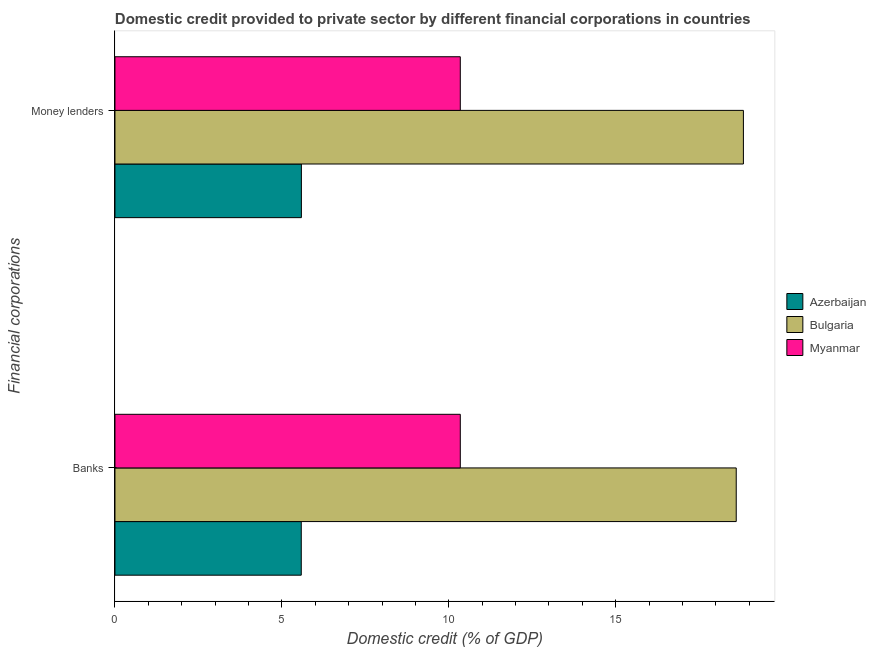How many groups of bars are there?
Offer a terse response. 2. Are the number of bars per tick equal to the number of legend labels?
Keep it short and to the point. Yes. How many bars are there on the 2nd tick from the bottom?
Offer a very short reply. 3. What is the label of the 1st group of bars from the top?
Give a very brief answer. Money lenders. What is the domestic credit provided by money lenders in Azerbaijan?
Offer a very short reply. 5.58. Across all countries, what is the maximum domestic credit provided by banks?
Your answer should be compact. 18.61. Across all countries, what is the minimum domestic credit provided by banks?
Your answer should be compact. 5.58. In which country was the domestic credit provided by money lenders maximum?
Your answer should be compact. Bulgaria. In which country was the domestic credit provided by money lenders minimum?
Provide a succinct answer. Azerbaijan. What is the total domestic credit provided by money lenders in the graph?
Keep it short and to the point. 34.76. What is the difference between the domestic credit provided by money lenders in Azerbaijan and that in Bulgaria?
Give a very brief answer. -13.24. What is the difference between the domestic credit provided by banks in Myanmar and the domestic credit provided by money lenders in Bulgaria?
Offer a terse response. -8.48. What is the average domestic credit provided by money lenders per country?
Make the answer very short. 11.59. What is the difference between the domestic credit provided by money lenders and domestic credit provided by banks in Azerbaijan?
Keep it short and to the point. 0. In how many countries, is the domestic credit provided by banks greater than 4 %?
Offer a terse response. 3. What is the ratio of the domestic credit provided by money lenders in Myanmar to that in Bulgaria?
Provide a succinct answer. 0.55. Is the domestic credit provided by money lenders in Bulgaria less than that in Azerbaijan?
Ensure brevity in your answer.  No. In how many countries, is the domestic credit provided by money lenders greater than the average domestic credit provided by money lenders taken over all countries?
Make the answer very short. 1. What does the 1st bar from the top in Money lenders represents?
Your response must be concise. Myanmar. What does the 1st bar from the bottom in Money lenders represents?
Make the answer very short. Azerbaijan. How many bars are there?
Ensure brevity in your answer.  6. Are all the bars in the graph horizontal?
Ensure brevity in your answer.  Yes. Are the values on the major ticks of X-axis written in scientific E-notation?
Give a very brief answer. No. Does the graph contain any zero values?
Make the answer very short. No. Does the graph contain grids?
Your answer should be compact. No. How many legend labels are there?
Your answer should be compact. 3. How are the legend labels stacked?
Give a very brief answer. Vertical. What is the title of the graph?
Your response must be concise. Domestic credit provided to private sector by different financial corporations in countries. What is the label or title of the X-axis?
Make the answer very short. Domestic credit (% of GDP). What is the label or title of the Y-axis?
Your answer should be very brief. Financial corporations. What is the Domestic credit (% of GDP) of Azerbaijan in Banks?
Your answer should be compact. 5.58. What is the Domestic credit (% of GDP) of Bulgaria in Banks?
Ensure brevity in your answer.  18.61. What is the Domestic credit (% of GDP) in Myanmar in Banks?
Your answer should be compact. 10.34. What is the Domestic credit (% of GDP) of Azerbaijan in Money lenders?
Offer a very short reply. 5.58. What is the Domestic credit (% of GDP) in Bulgaria in Money lenders?
Give a very brief answer. 18.83. What is the Domestic credit (% of GDP) in Myanmar in Money lenders?
Keep it short and to the point. 10.34. Across all Financial corporations, what is the maximum Domestic credit (% of GDP) of Azerbaijan?
Make the answer very short. 5.58. Across all Financial corporations, what is the maximum Domestic credit (% of GDP) in Bulgaria?
Give a very brief answer. 18.83. Across all Financial corporations, what is the maximum Domestic credit (% of GDP) of Myanmar?
Your answer should be compact. 10.34. Across all Financial corporations, what is the minimum Domestic credit (% of GDP) of Azerbaijan?
Your answer should be very brief. 5.58. Across all Financial corporations, what is the minimum Domestic credit (% of GDP) of Bulgaria?
Offer a terse response. 18.61. Across all Financial corporations, what is the minimum Domestic credit (% of GDP) in Myanmar?
Your response must be concise. 10.34. What is the total Domestic credit (% of GDP) of Azerbaijan in the graph?
Offer a very short reply. 11.17. What is the total Domestic credit (% of GDP) in Bulgaria in the graph?
Your response must be concise. 37.44. What is the total Domestic credit (% of GDP) in Myanmar in the graph?
Provide a short and direct response. 20.69. What is the difference between the Domestic credit (% of GDP) of Azerbaijan in Banks and that in Money lenders?
Give a very brief answer. -0. What is the difference between the Domestic credit (% of GDP) of Bulgaria in Banks and that in Money lenders?
Provide a short and direct response. -0.22. What is the difference between the Domestic credit (% of GDP) of Azerbaijan in Banks and the Domestic credit (% of GDP) of Bulgaria in Money lenders?
Offer a very short reply. -13.25. What is the difference between the Domestic credit (% of GDP) in Azerbaijan in Banks and the Domestic credit (% of GDP) in Myanmar in Money lenders?
Your response must be concise. -4.76. What is the difference between the Domestic credit (% of GDP) of Bulgaria in Banks and the Domestic credit (% of GDP) of Myanmar in Money lenders?
Offer a terse response. 8.27. What is the average Domestic credit (% of GDP) in Azerbaijan per Financial corporations?
Provide a succinct answer. 5.58. What is the average Domestic credit (% of GDP) of Bulgaria per Financial corporations?
Provide a succinct answer. 18.72. What is the average Domestic credit (% of GDP) in Myanmar per Financial corporations?
Make the answer very short. 10.34. What is the difference between the Domestic credit (% of GDP) in Azerbaijan and Domestic credit (% of GDP) in Bulgaria in Banks?
Make the answer very short. -13.03. What is the difference between the Domestic credit (% of GDP) of Azerbaijan and Domestic credit (% of GDP) of Myanmar in Banks?
Provide a short and direct response. -4.76. What is the difference between the Domestic credit (% of GDP) of Bulgaria and Domestic credit (% of GDP) of Myanmar in Banks?
Offer a very short reply. 8.27. What is the difference between the Domestic credit (% of GDP) in Azerbaijan and Domestic credit (% of GDP) in Bulgaria in Money lenders?
Make the answer very short. -13.24. What is the difference between the Domestic credit (% of GDP) of Azerbaijan and Domestic credit (% of GDP) of Myanmar in Money lenders?
Your answer should be compact. -4.76. What is the difference between the Domestic credit (% of GDP) in Bulgaria and Domestic credit (% of GDP) in Myanmar in Money lenders?
Provide a succinct answer. 8.48. What is the ratio of the Domestic credit (% of GDP) of Azerbaijan in Banks to that in Money lenders?
Offer a very short reply. 1. What is the ratio of the Domestic credit (% of GDP) in Bulgaria in Banks to that in Money lenders?
Keep it short and to the point. 0.99. What is the ratio of the Domestic credit (% of GDP) in Myanmar in Banks to that in Money lenders?
Give a very brief answer. 1. What is the difference between the highest and the second highest Domestic credit (% of GDP) of Azerbaijan?
Keep it short and to the point. 0. What is the difference between the highest and the second highest Domestic credit (% of GDP) of Bulgaria?
Offer a terse response. 0.22. What is the difference between the highest and the second highest Domestic credit (% of GDP) of Myanmar?
Your answer should be compact. 0. What is the difference between the highest and the lowest Domestic credit (% of GDP) in Azerbaijan?
Make the answer very short. 0. What is the difference between the highest and the lowest Domestic credit (% of GDP) of Bulgaria?
Offer a very short reply. 0.22. What is the difference between the highest and the lowest Domestic credit (% of GDP) of Myanmar?
Provide a succinct answer. 0. 